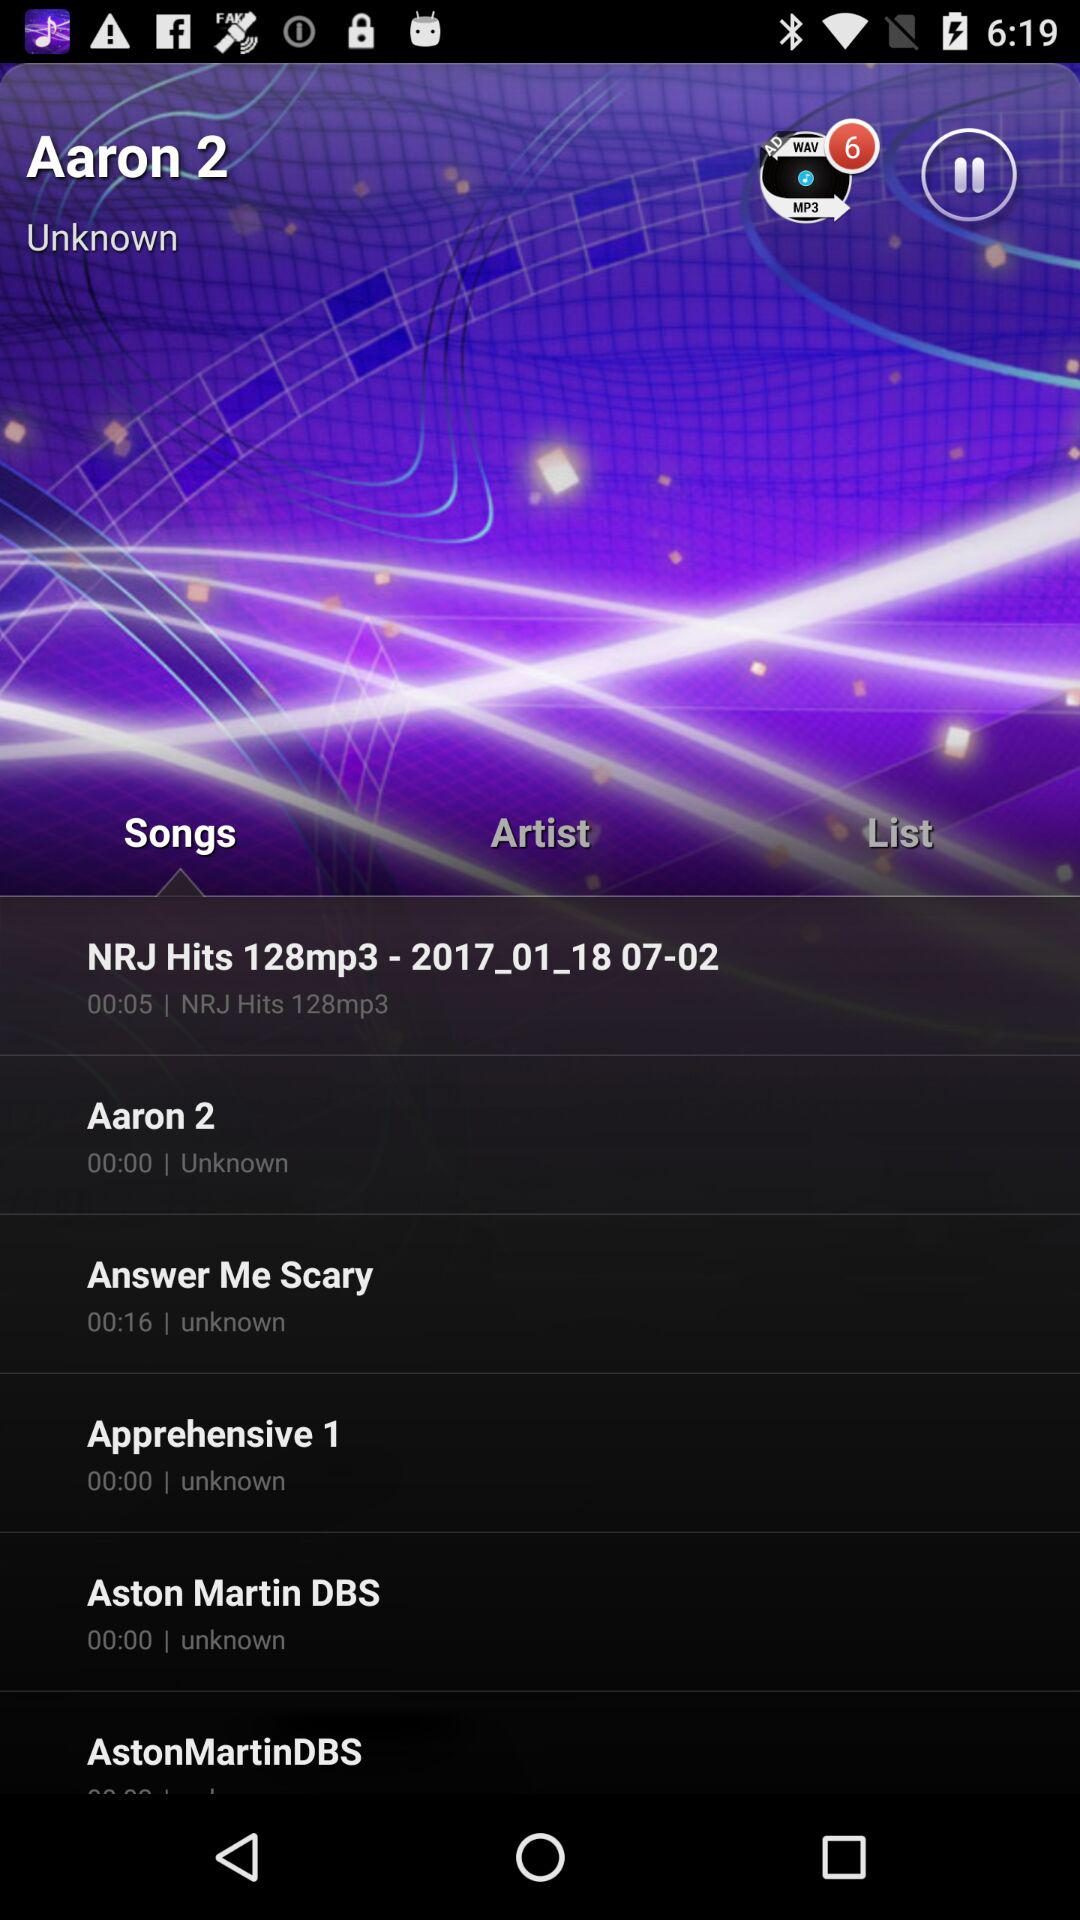What song is currently playing? The currently playing song is "Aaron 2". 